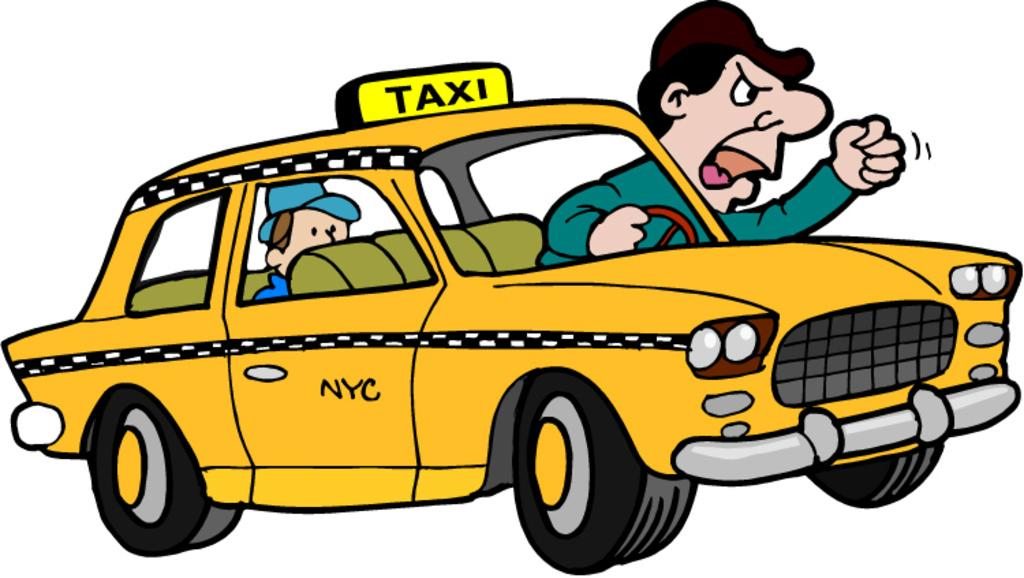<image>
Share a concise interpretation of the image provided. Someone created an unflattering cartoon of a New York City taxi, irate taxi driver, and rider! 